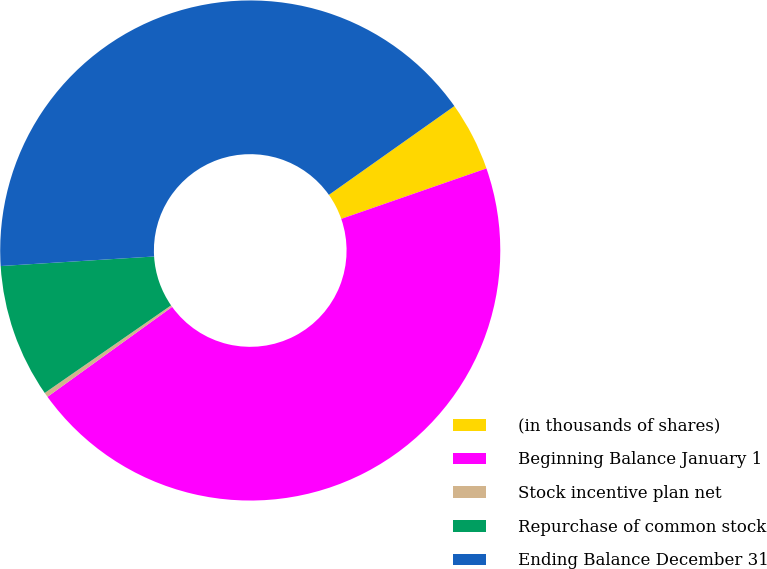<chart> <loc_0><loc_0><loc_500><loc_500><pie_chart><fcel>(in thousands of shares)<fcel>Beginning Balance January 1<fcel>Stock incentive plan net<fcel>Repurchase of common stock<fcel>Ending Balance December 31<nl><fcel>4.48%<fcel>45.38%<fcel>0.3%<fcel>8.66%<fcel>41.2%<nl></chart> 